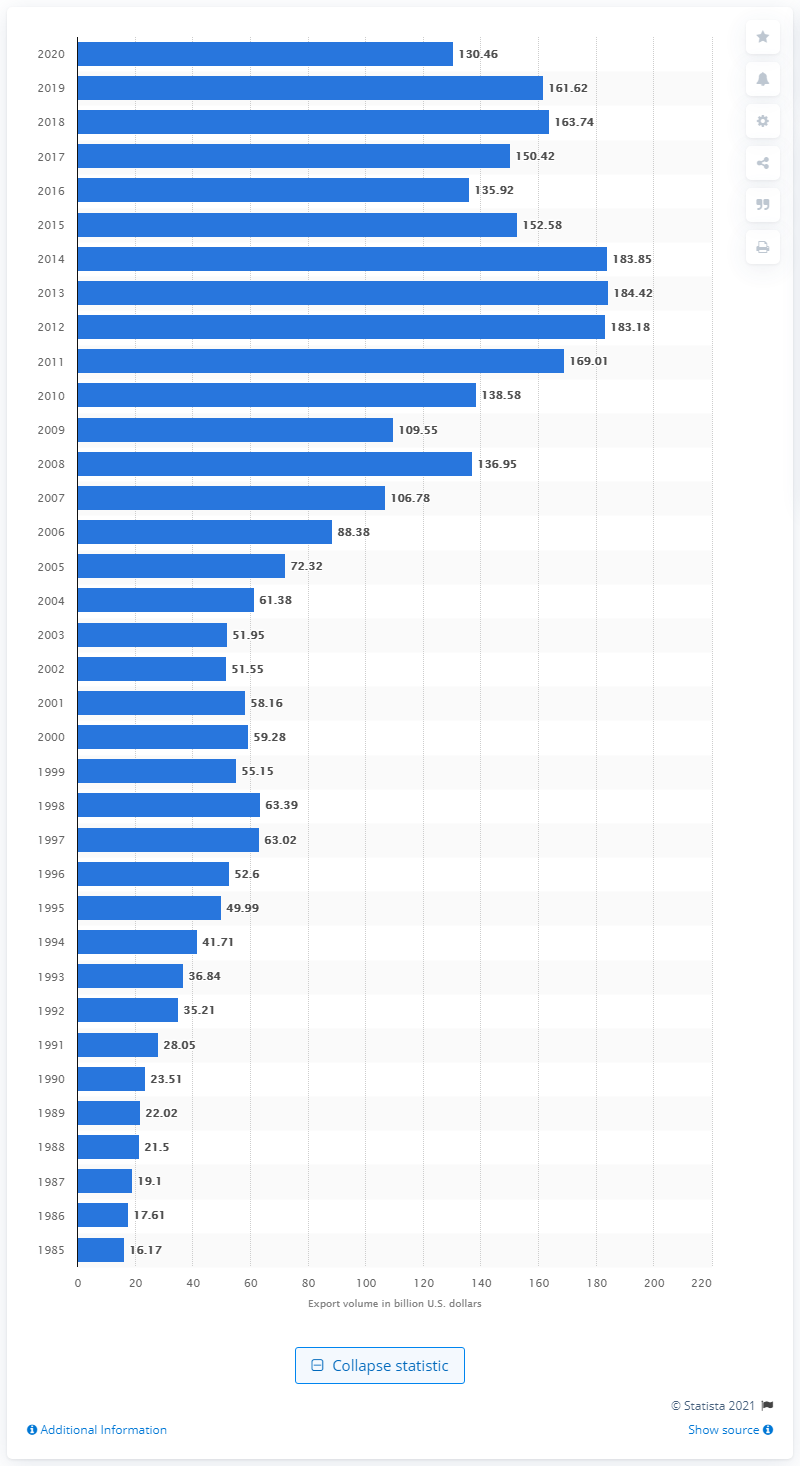Specify some key components in this picture. In 2020, the value of U.S. exports to South and Central America was 130.46 billion dollars. 